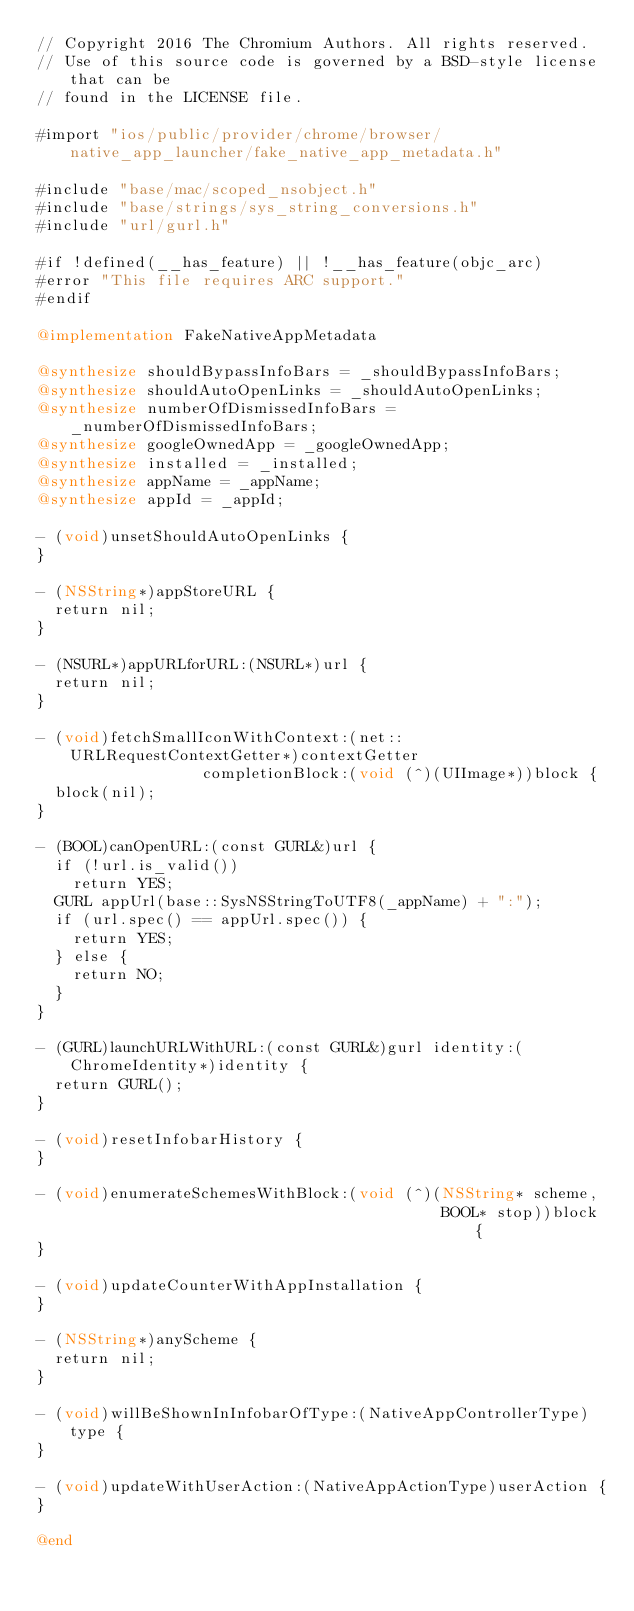Convert code to text. <code><loc_0><loc_0><loc_500><loc_500><_ObjectiveC_>// Copyright 2016 The Chromium Authors. All rights reserved.
// Use of this source code is governed by a BSD-style license that can be
// found in the LICENSE file.

#import "ios/public/provider/chrome/browser/native_app_launcher/fake_native_app_metadata.h"

#include "base/mac/scoped_nsobject.h"
#include "base/strings/sys_string_conversions.h"
#include "url/gurl.h"

#if !defined(__has_feature) || !__has_feature(objc_arc)
#error "This file requires ARC support."
#endif

@implementation FakeNativeAppMetadata

@synthesize shouldBypassInfoBars = _shouldBypassInfoBars;
@synthesize shouldAutoOpenLinks = _shouldAutoOpenLinks;
@synthesize numberOfDismissedInfoBars = _numberOfDismissedInfoBars;
@synthesize googleOwnedApp = _googleOwnedApp;
@synthesize installed = _installed;
@synthesize appName = _appName;
@synthesize appId = _appId;

- (void)unsetShouldAutoOpenLinks {
}

- (NSString*)appStoreURL {
  return nil;
}

- (NSURL*)appURLforURL:(NSURL*)url {
  return nil;
}

- (void)fetchSmallIconWithContext:(net::URLRequestContextGetter*)contextGetter
                  completionBlock:(void (^)(UIImage*))block {
  block(nil);
}

- (BOOL)canOpenURL:(const GURL&)url {
  if (!url.is_valid())
    return YES;
  GURL appUrl(base::SysNSStringToUTF8(_appName) + ":");
  if (url.spec() == appUrl.spec()) {
    return YES;
  } else {
    return NO;
  }
}

- (GURL)launchURLWithURL:(const GURL&)gurl identity:(ChromeIdentity*)identity {
  return GURL();
}

- (void)resetInfobarHistory {
}

- (void)enumerateSchemesWithBlock:(void (^)(NSString* scheme,
                                            BOOL* stop))block {
}

- (void)updateCounterWithAppInstallation {
}

- (NSString*)anyScheme {
  return nil;
}

- (void)willBeShownInInfobarOfType:(NativeAppControllerType)type {
}

- (void)updateWithUserAction:(NativeAppActionType)userAction {
}

@end
</code> 